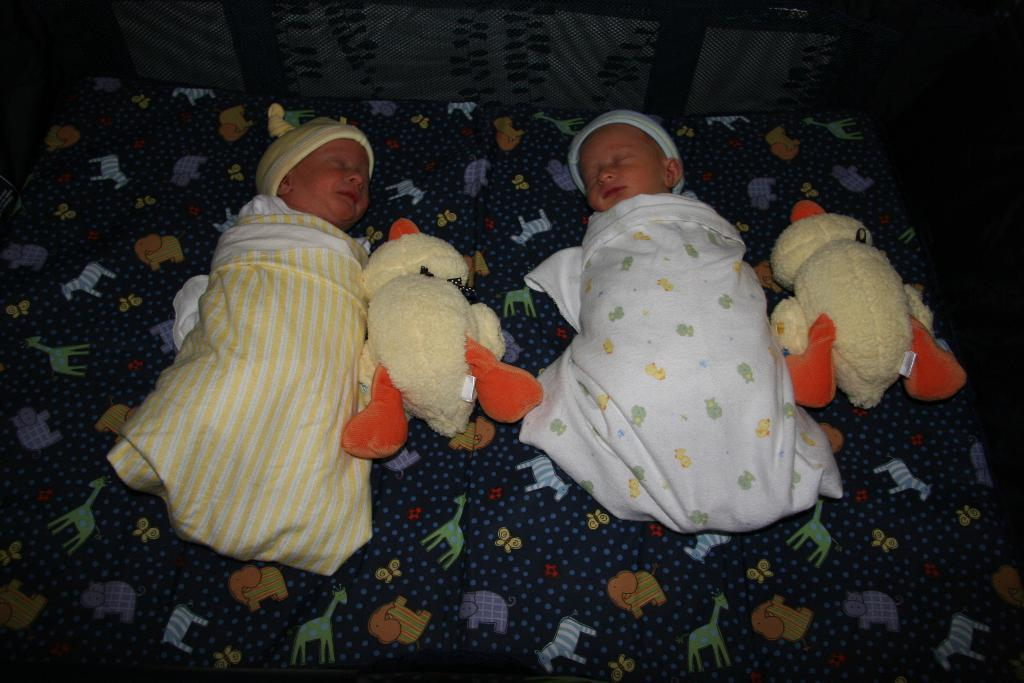What is present in the image? There are babies in the image. What else can be seen in the image? There are two toys on the bed. How many crackers are present in the image? There is no mention of crackers in the image, so we cannot determine the amount. 